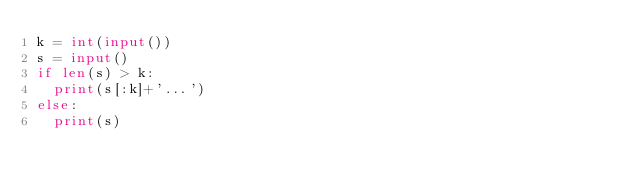Convert code to text. <code><loc_0><loc_0><loc_500><loc_500><_Python_>k = int(input())
s = input()
if len(s) > k:
  print(s[:k]+'...')
else:
  print(s)</code> 